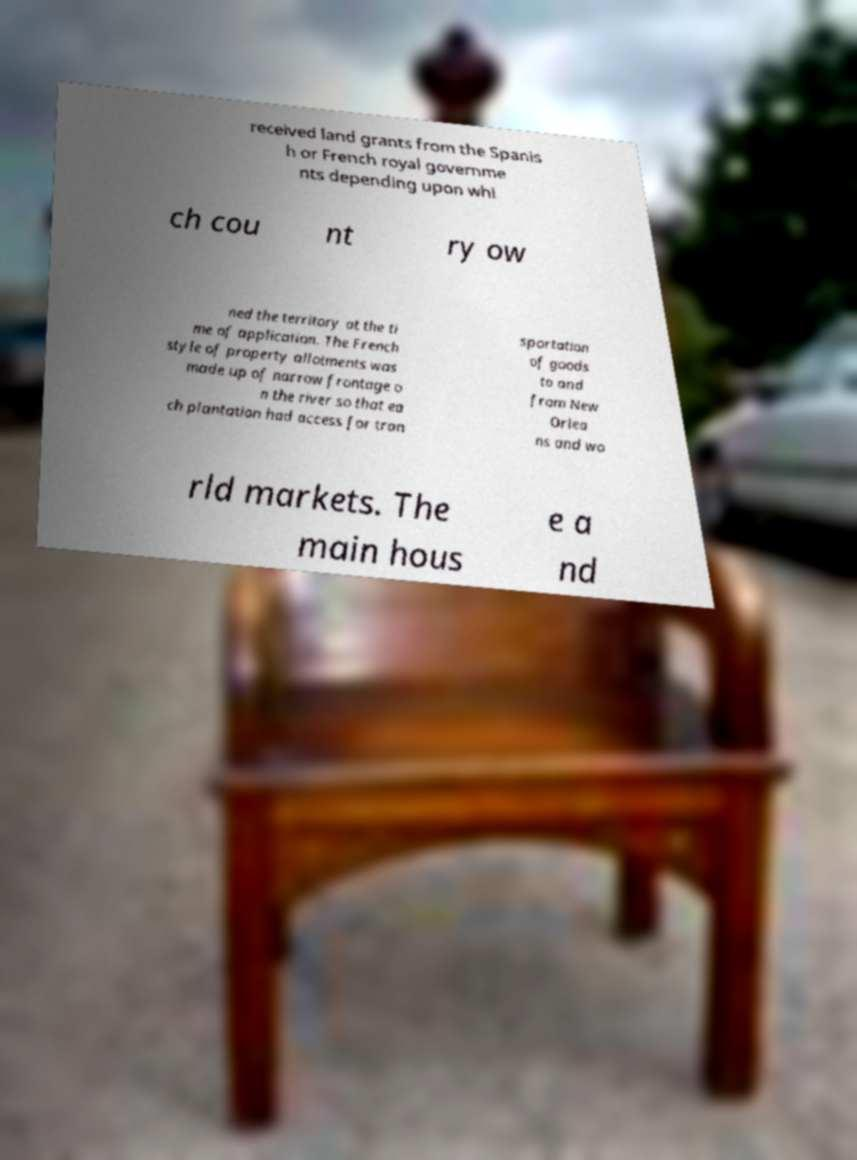Could you assist in decoding the text presented in this image and type it out clearly? received land grants from the Spanis h or French royal governme nts depending upon whi ch cou nt ry ow ned the territory at the ti me of application. The French style of property allotments was made up of narrow frontage o n the river so that ea ch plantation had access for tran sportation of goods to and from New Orlea ns and wo rld markets. The main hous e a nd 